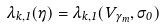Convert formula to latex. <formula><loc_0><loc_0><loc_500><loc_500>\lambda _ { k , 1 } ( \eta ) = \lambda _ { k , 1 } ( V _ { \gamma _ { m } } , \sigma _ { 0 } )</formula> 